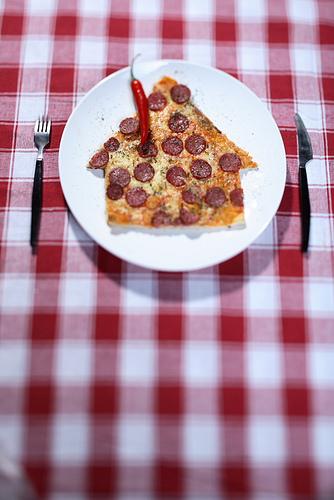What is the color of the pepper situated on top of the pizza?
Write a very short answer. Red. Is it likely the pepperonis are meant to be windows here?
Quick response, please. No. Where are the fork and knife located?
Keep it brief. Beside plate. Is the pizza in the picture a triangle or a circle?
Answer briefly. Triangle. 